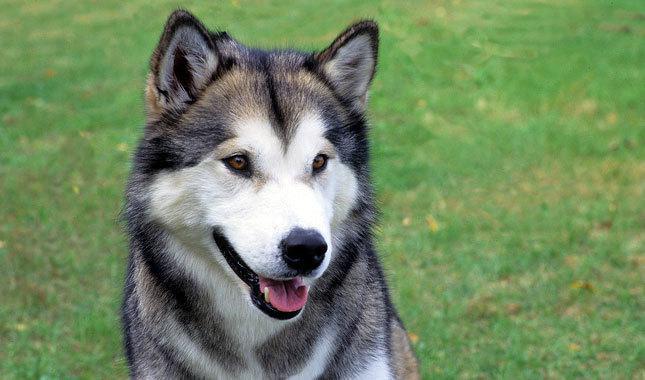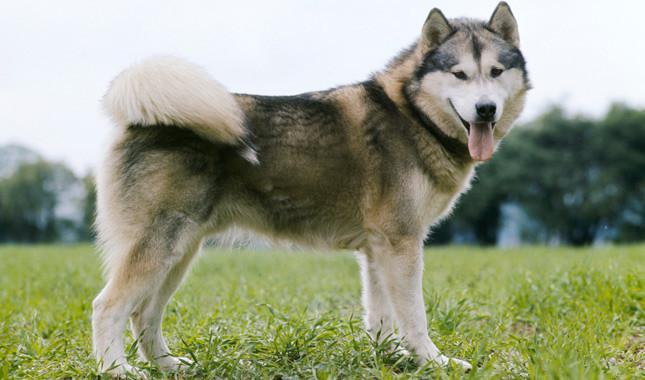The first image is the image on the left, the second image is the image on the right. For the images shown, is this caption "The right image contains one dog attached to a leash." true? Answer yes or no. No. The first image is the image on the left, the second image is the image on the right. Considering the images on both sides, is "Each image shows a husky standing on all fours, and the dog on the right wears a leash." valid? Answer yes or no. No. 